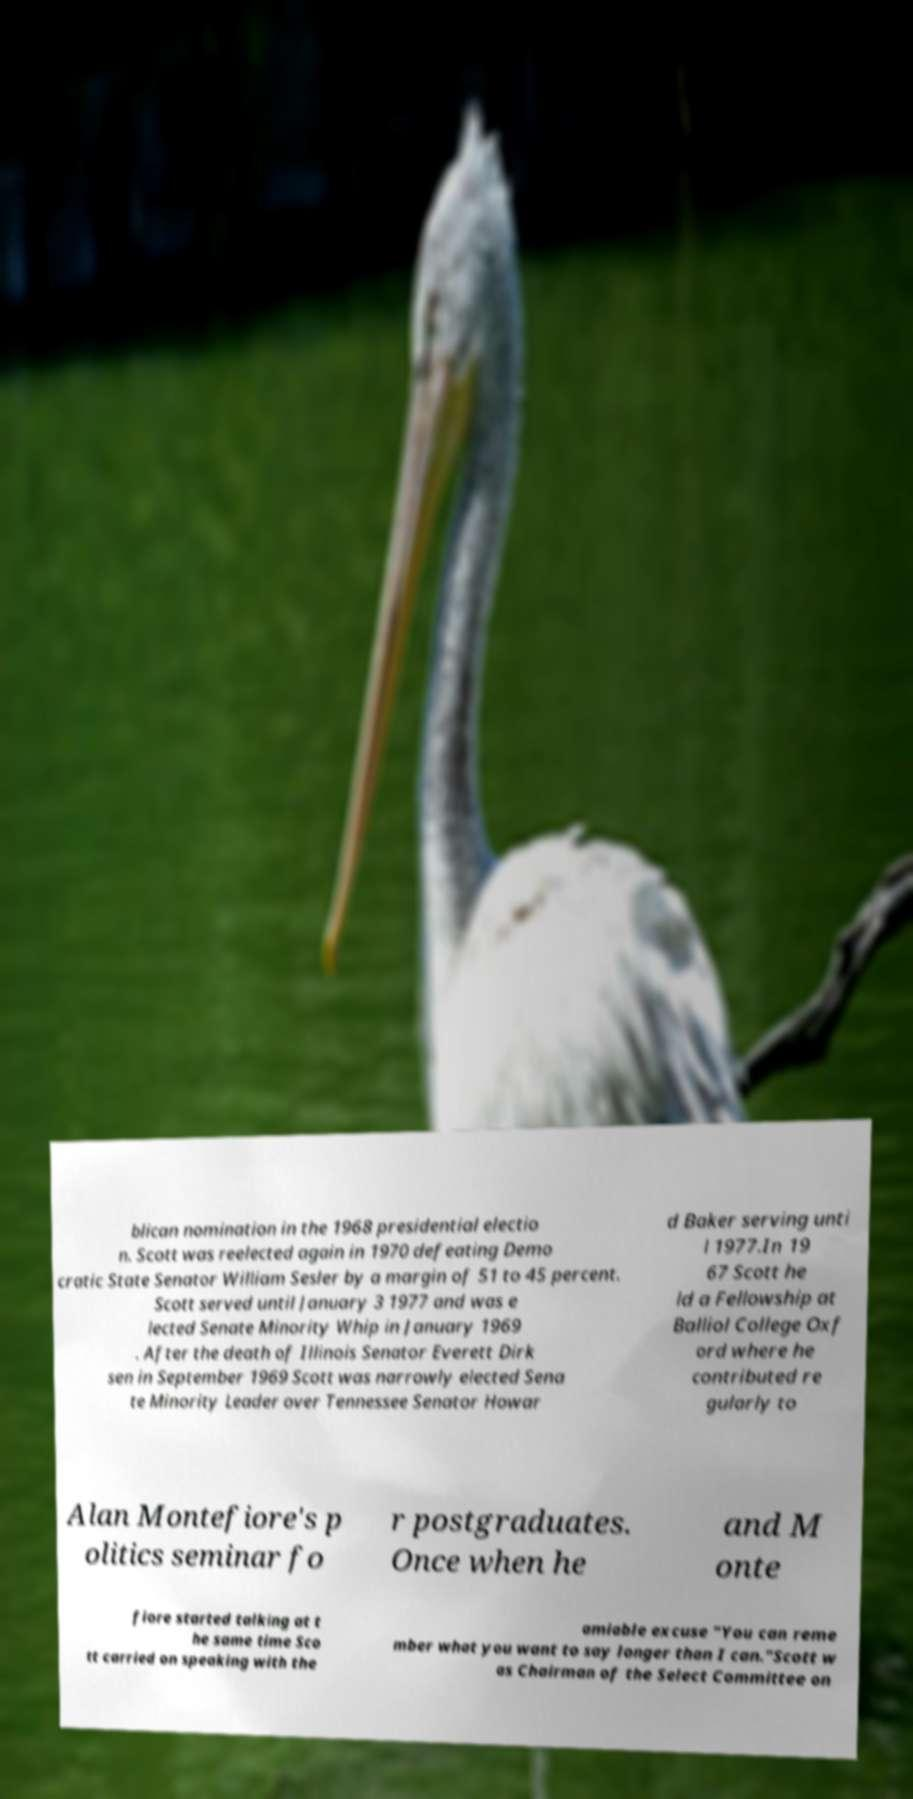Please identify and transcribe the text found in this image. blican nomination in the 1968 presidential electio n. Scott was reelected again in 1970 defeating Demo cratic State Senator William Sesler by a margin of 51 to 45 percent. Scott served until January 3 1977 and was e lected Senate Minority Whip in January 1969 . After the death of Illinois Senator Everett Dirk sen in September 1969 Scott was narrowly elected Sena te Minority Leader over Tennessee Senator Howar d Baker serving unti l 1977.In 19 67 Scott he ld a Fellowship at Balliol College Oxf ord where he contributed re gularly to Alan Montefiore's p olitics seminar fo r postgraduates. Once when he and M onte fiore started talking at t he same time Sco tt carried on speaking with the amiable excuse "You can reme mber what you want to say longer than I can."Scott w as Chairman of the Select Committee on 